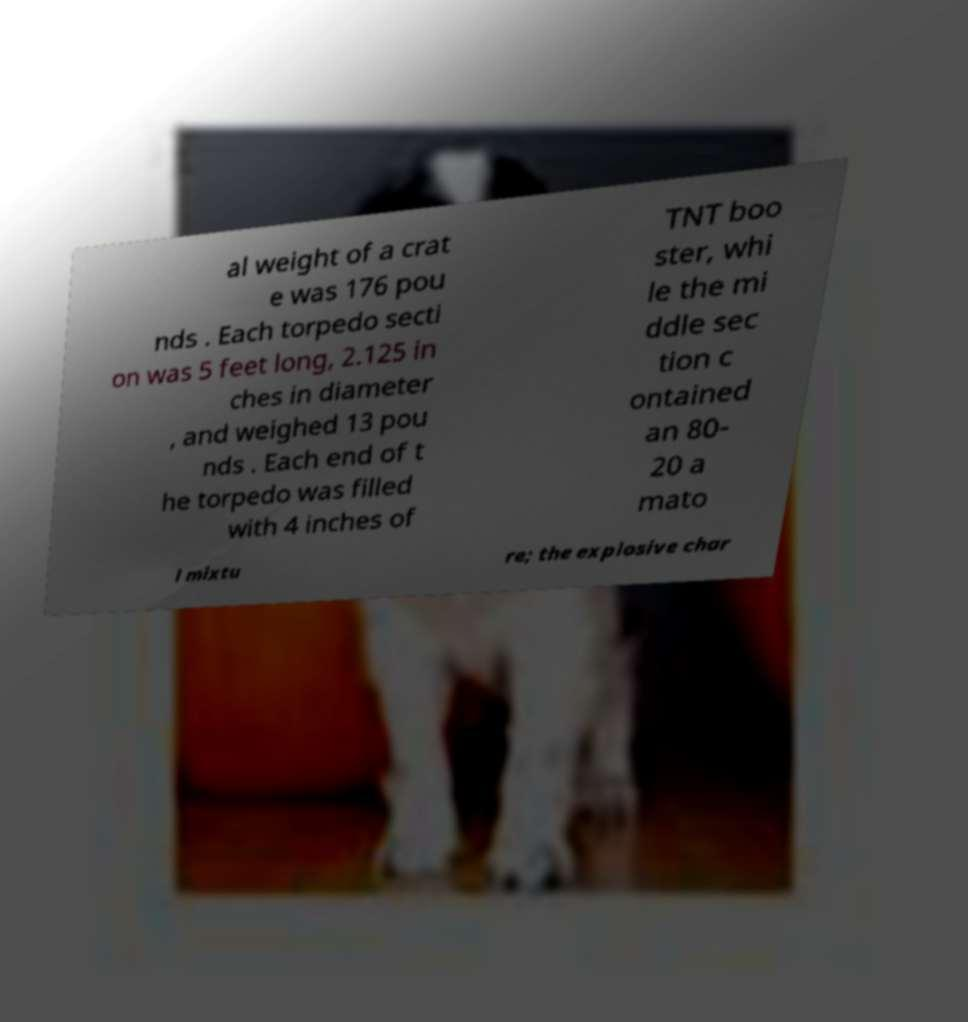Please identify and transcribe the text found in this image. al weight of a crat e was 176 pou nds . Each torpedo secti on was 5 feet long, 2.125 in ches in diameter , and weighed 13 pou nds . Each end of t he torpedo was filled with 4 inches of TNT boo ster, whi le the mi ddle sec tion c ontained an 80- 20 a mato l mixtu re; the explosive char 